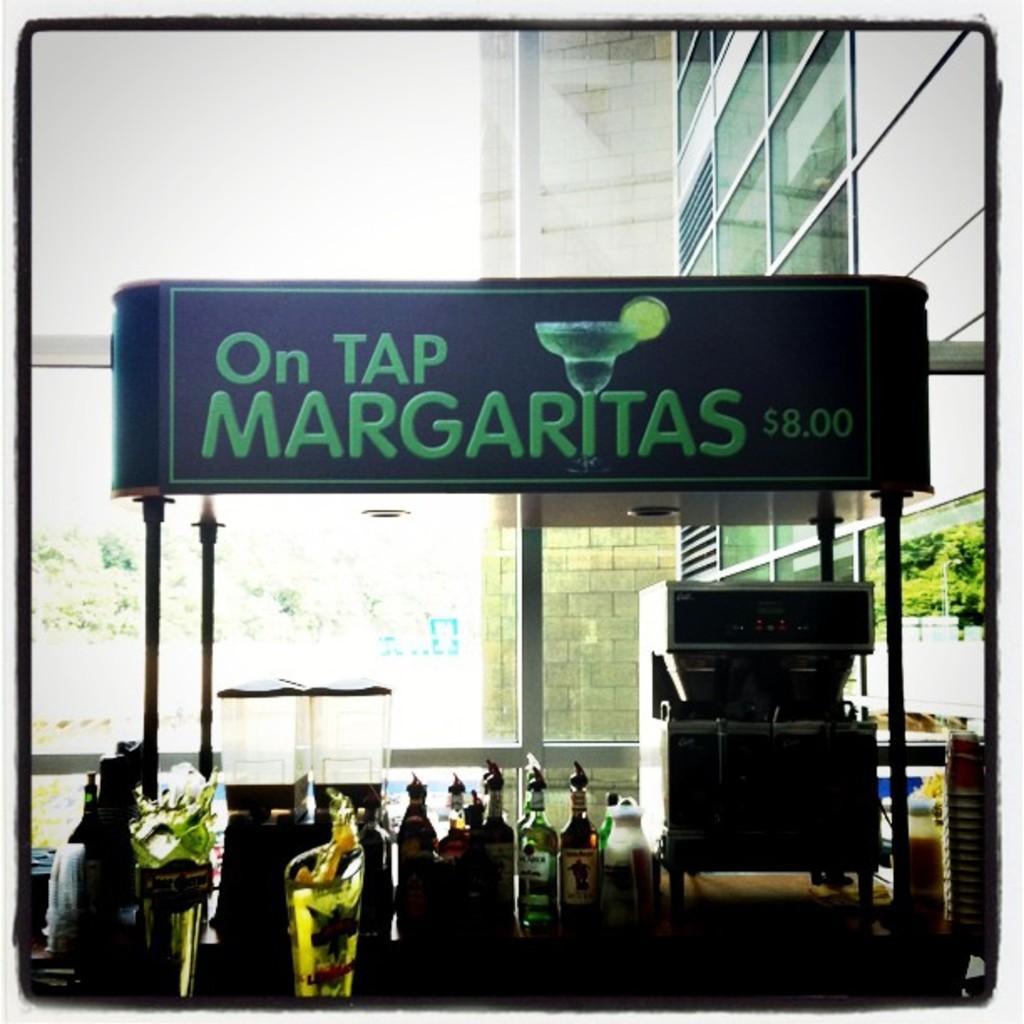In one or two sentences, can you explain what this image depicts? In the center of the image there are bottles and glasses on the table. In the background of the image there is a glass wall. There is a advertisement board. There is a machine. There is a wall. 